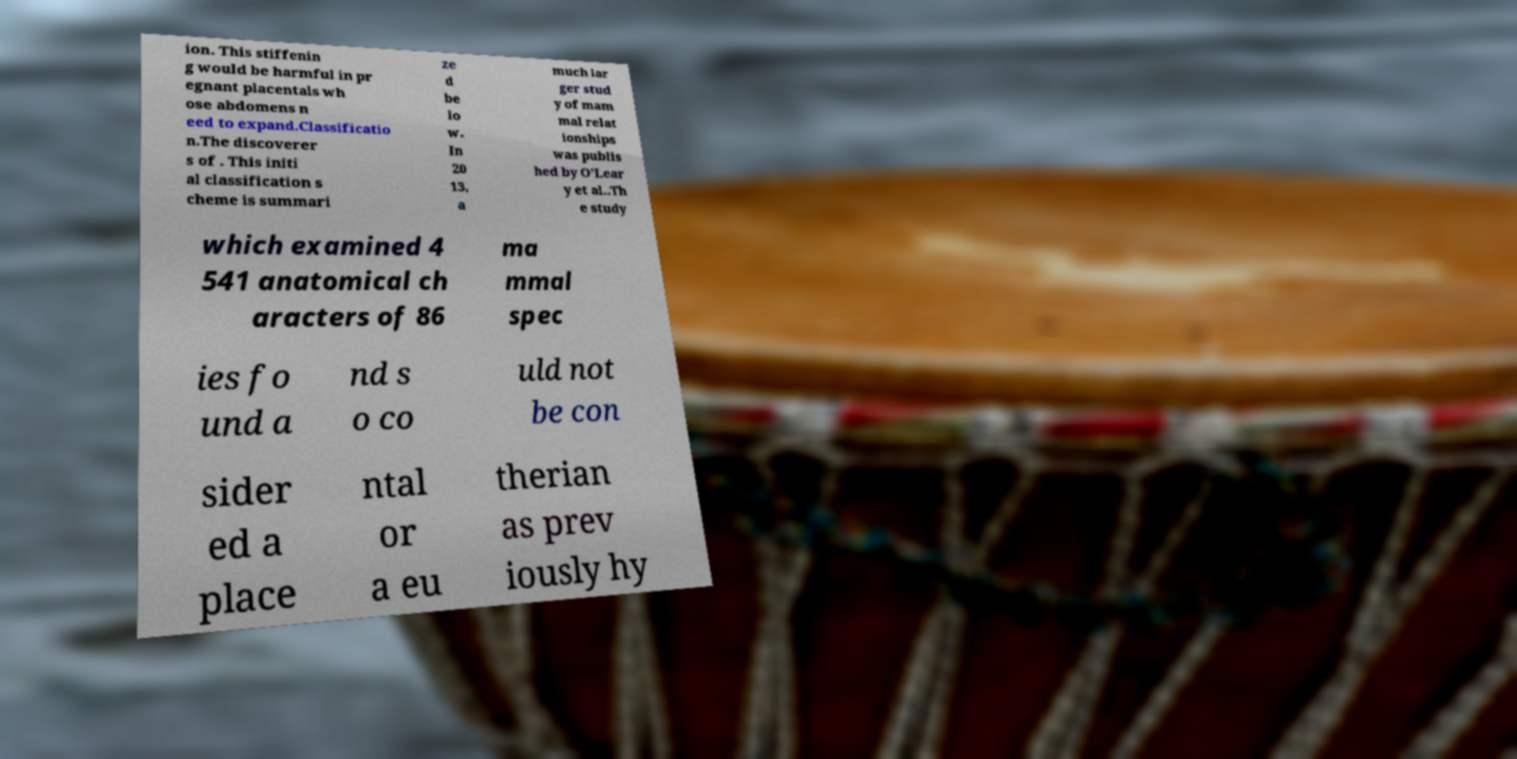I need the written content from this picture converted into text. Can you do that? ion. This stiffenin g would be harmful in pr egnant placentals wh ose abdomens n eed to expand.Classificatio n.The discoverer s of . This initi al classification s cheme is summari ze d be lo w. In 20 13, a much lar ger stud y of mam mal relat ionships was publis hed by O'Lear y et al..Th e study which examined 4 541 anatomical ch aracters of 86 ma mmal spec ies fo und a nd s o co uld not be con sider ed a place ntal or a eu therian as prev iously hy 